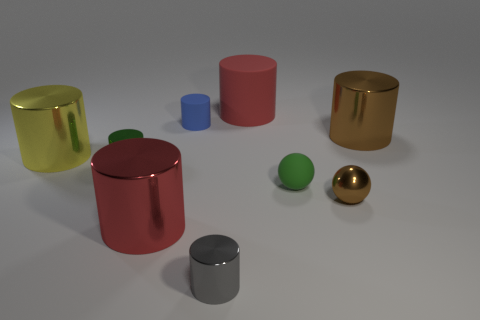Does the green metallic cylinder have the same size as the brown metal object that is in front of the rubber ball?
Your answer should be compact. Yes. There is a large thing that is the same color as the large rubber cylinder; what material is it?
Provide a short and direct response. Metal. There is a rubber cylinder that is to the left of the large thing that is behind the metal cylinder that is behind the yellow cylinder; how big is it?
Make the answer very short. Small. Is the number of tiny brown balls that are in front of the big brown cylinder greater than the number of brown shiny cylinders that are left of the gray metallic thing?
Your answer should be very brief. Yes. What number of cylinders are behind the big brown cylinder that is in front of the large red matte cylinder?
Your answer should be very brief. 2. Is there a thing of the same color as the matte sphere?
Your response must be concise. Yes. Does the gray metal thing have the same size as the yellow metal cylinder?
Your answer should be compact. No. The large red object that is on the left side of the tiny metal object in front of the red metal cylinder is made of what material?
Keep it short and to the point. Metal. There is another small object that is the same shape as the tiny brown metallic thing; what is its material?
Ensure brevity in your answer.  Rubber. Does the red cylinder that is in front of the red rubber cylinder have the same size as the brown cylinder?
Provide a short and direct response. Yes. 